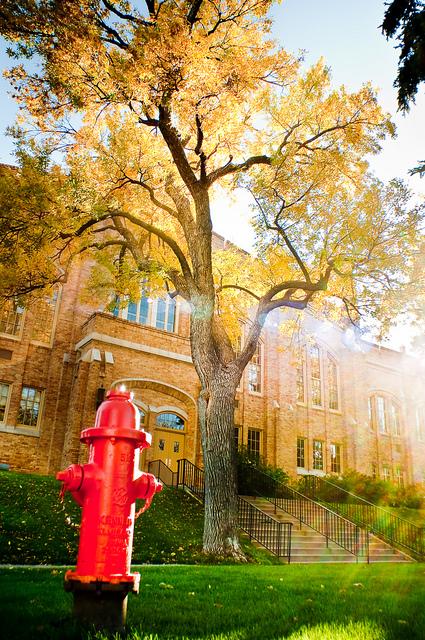Is it autumn?
Give a very brief answer. Yes. Is it sunny outside?
Keep it brief. Yes. What color is the stone walls?
Answer briefly. Brown. Is there a lake here?
Keep it brief. No. What color are the blooms on this tree?
Answer briefly. Yellow. Has the hydrant been painted recently?
Be succinct. Yes. What color is the fire hydrant?
Answer briefly. Red. What substance is on the fire hydrant?
Be succinct. Paint. Are there tall trees behind the hydrant?
Quick response, please. Yes. Does this grass need to be watered?
Give a very brief answer. No. Do fire hydrants normal look this way sticking out of the ground?
Answer briefly. Yes. What are the weather conditions?
Write a very short answer. Sunny. 